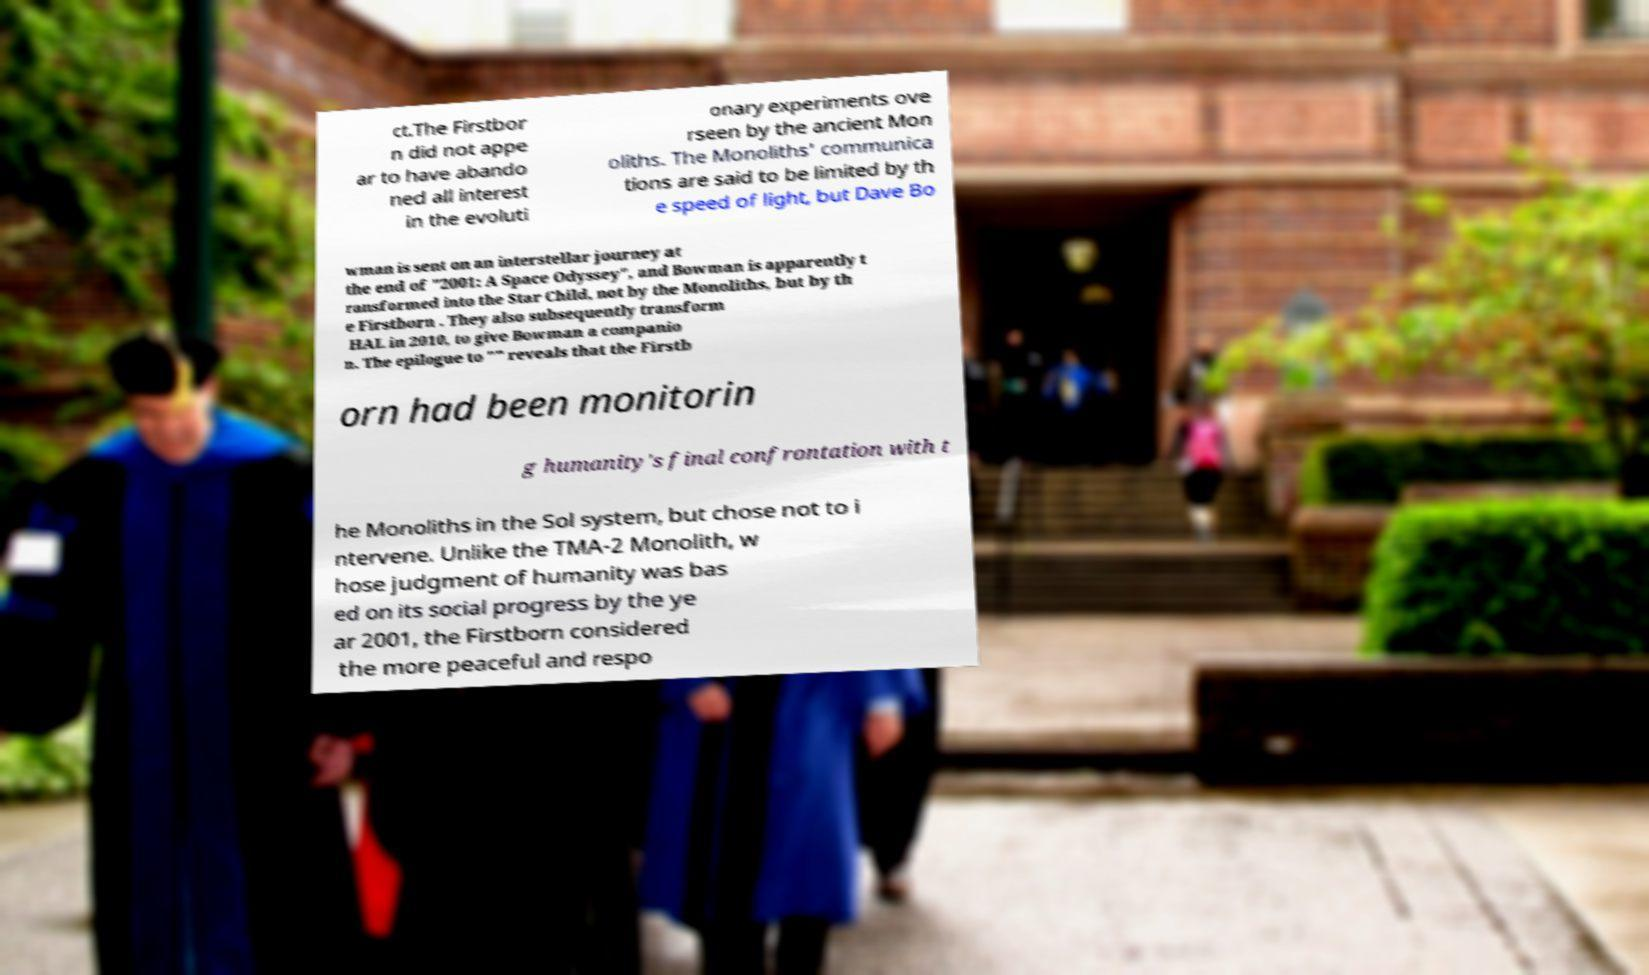Can you read and provide the text displayed in the image?This photo seems to have some interesting text. Can you extract and type it out for me? ct.The Firstbor n did not appe ar to have abando ned all interest in the evoluti onary experiments ove rseen by the ancient Mon oliths. The Monoliths' communica tions are said to be limited by th e speed of light, but Dave Bo wman is sent on an interstellar journey at the end of "2001: A Space Odyssey", and Bowman is apparently t ransformed into the Star Child, not by the Monoliths, but by th e Firstborn . They also subsequently transform HAL in 2010, to give Bowman a companio n. The epilogue to "" reveals that the Firstb orn had been monitorin g humanity's final confrontation with t he Monoliths in the Sol system, but chose not to i ntervene. Unlike the TMA-2 Monolith, w hose judgment of humanity was bas ed on its social progress by the ye ar 2001, the Firstborn considered the more peaceful and respo 